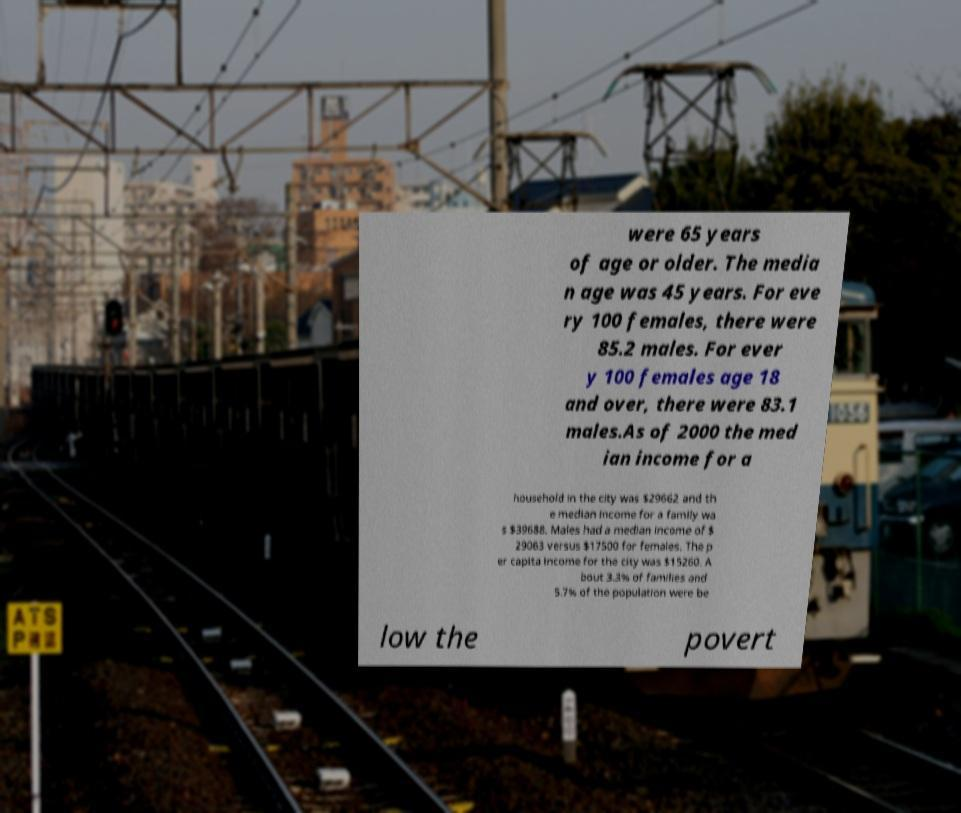Could you extract and type out the text from this image? were 65 years of age or older. The media n age was 45 years. For eve ry 100 females, there were 85.2 males. For ever y 100 females age 18 and over, there were 83.1 males.As of 2000 the med ian income for a household in the city was $29662 and th e median income for a family wa s $39688. Males had a median income of $ 29063 versus $17500 for females. The p er capita income for the city was $15260. A bout 3.3% of families and 5.7% of the population were be low the povert 